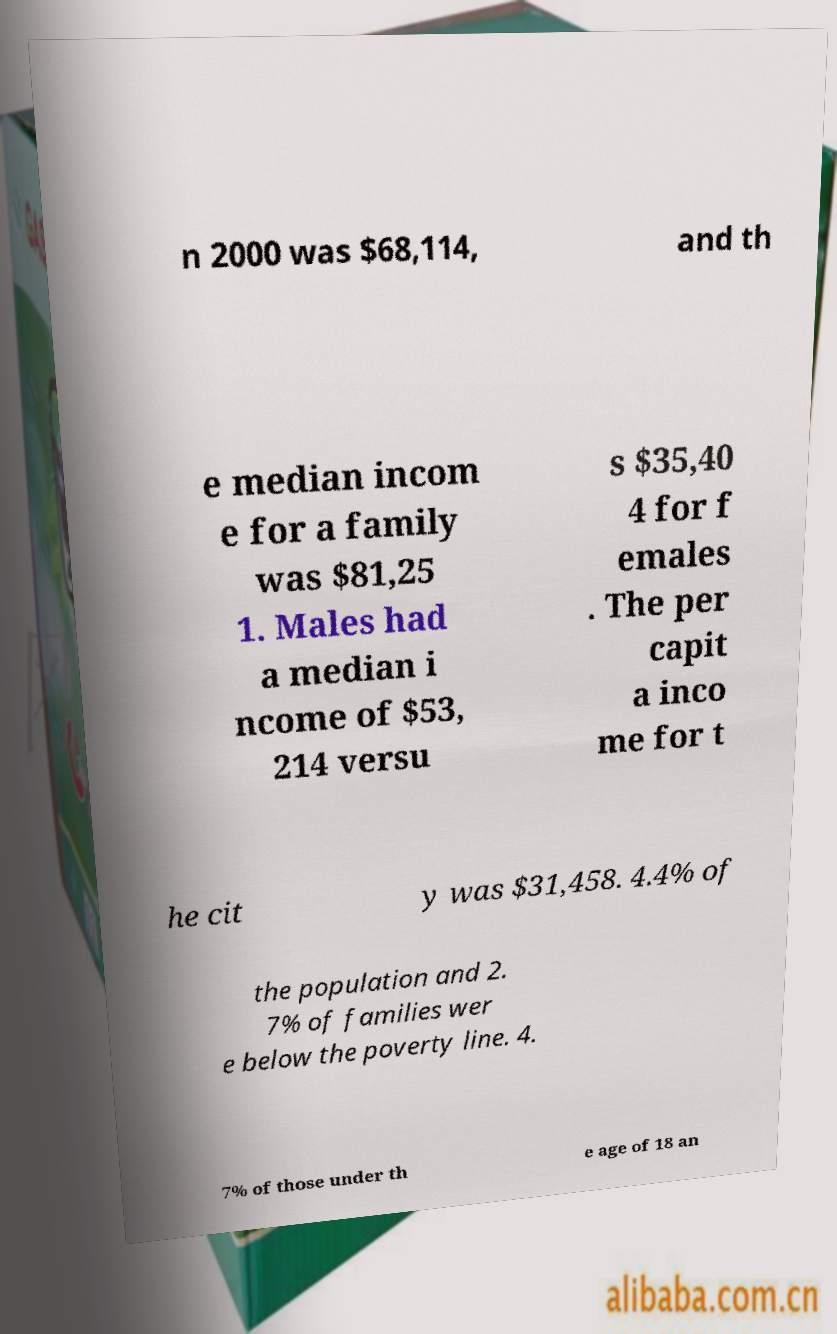Could you extract and type out the text from this image? n 2000 was $68,114, and th e median incom e for a family was $81,25 1. Males had a median i ncome of $53, 214 versu s $35,40 4 for f emales . The per capit a inco me for t he cit y was $31,458. 4.4% of the population and 2. 7% of families wer e below the poverty line. 4. 7% of those under th e age of 18 an 